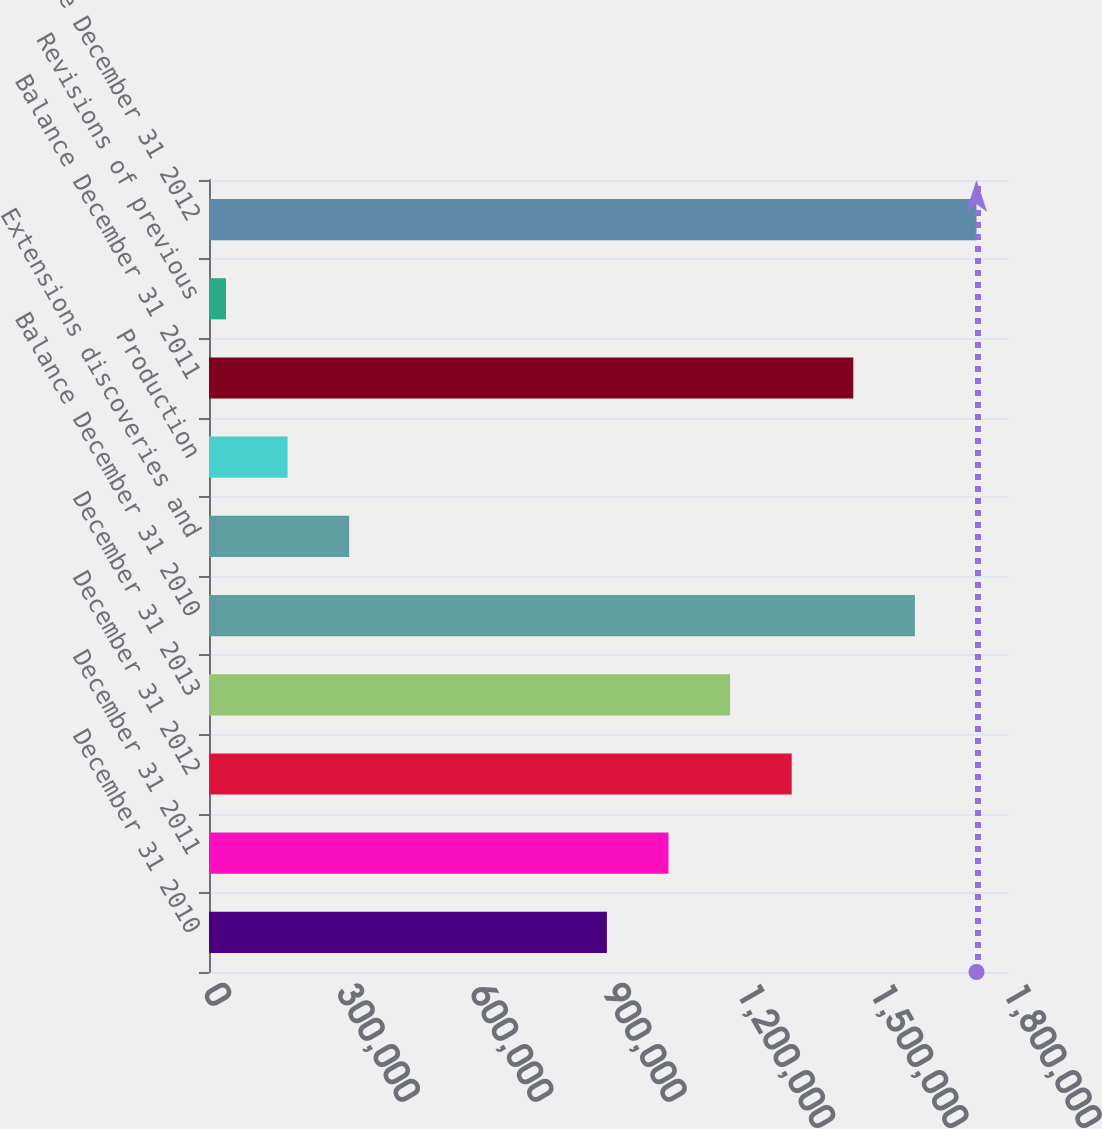Convert chart. <chart><loc_0><loc_0><loc_500><loc_500><bar_chart><fcel>December 31 2010<fcel>December 31 2011<fcel>December 31 2012<fcel>December 31 2013<fcel>Balance December 31 2010<fcel>Extensions discoveries and<fcel>Production<fcel>Balance December 31 2011<fcel>Revisions of previous<fcel>Balance December 31 2012<nl><fcel>895223<fcel>1.03383e+06<fcel>1.31106e+06<fcel>1.17245e+06<fcel>1.58828e+06<fcel>315395<fcel>176784<fcel>1.44967e+06<fcel>38172<fcel>1.72689e+06<nl></chart> 